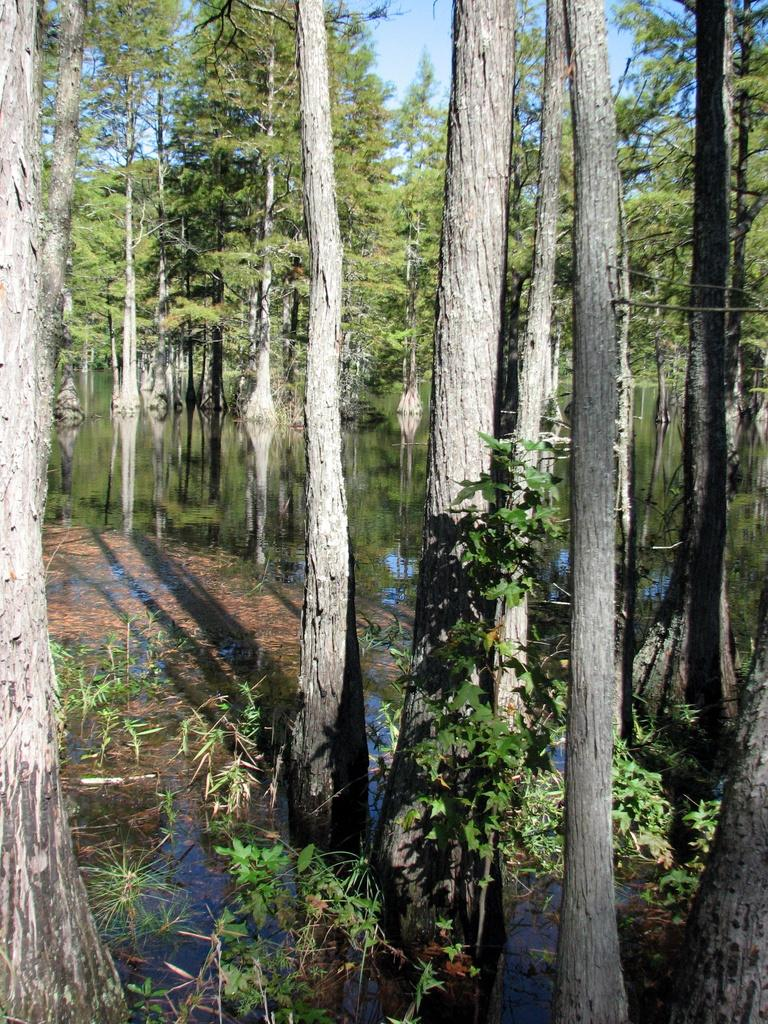What type of living organisms can be seen in the image? Plants and trees are visible in the image. What natural element can be seen in the image? Water is visible in the image. What is visible in the background of the image? The sky is visible in the background of the image. Can you tell me how many dogs are present in the image? There are no dogs present in the image. What type of pet can be seen interacting with the plants in the image? There is no pet present in the image; only plants, trees, water, and the sky are visible. 